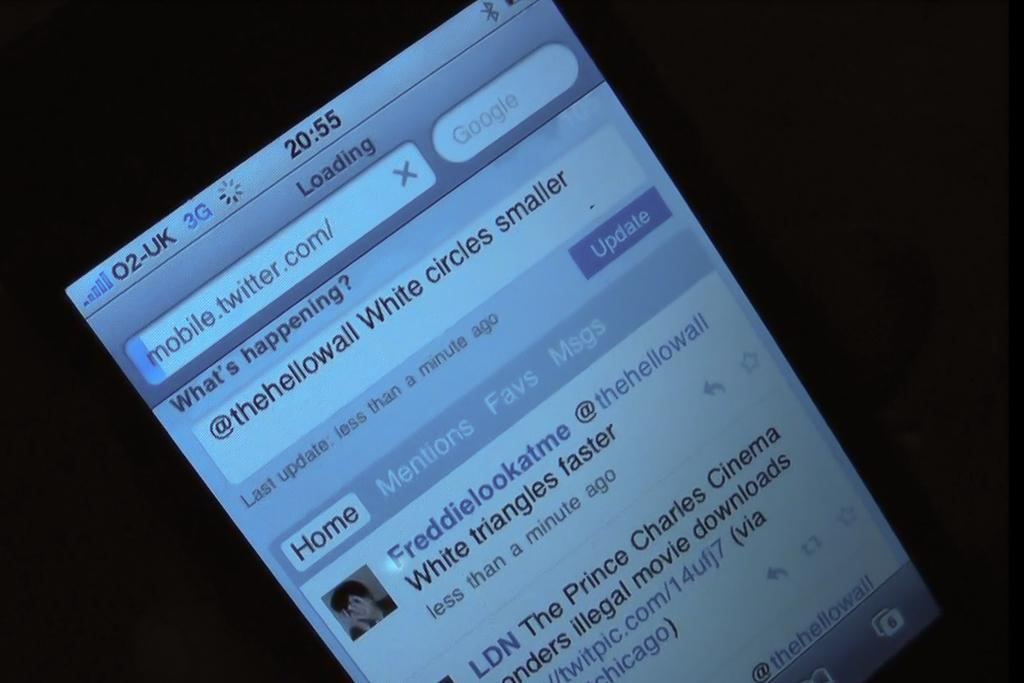<image>
Present a compact description of the photo's key features. A cell phone screen loading up mobile twitter with the time being 20:55 